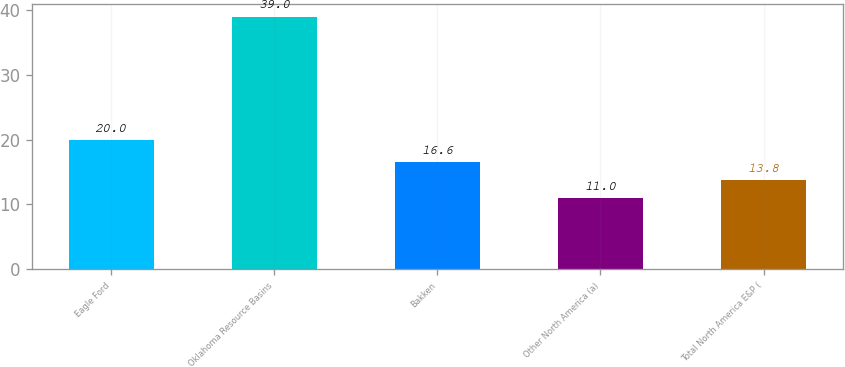Convert chart. <chart><loc_0><loc_0><loc_500><loc_500><bar_chart><fcel>Eagle Ford<fcel>Oklahoma Resource Basins<fcel>Bakken<fcel>Other North America (a)<fcel>Total North America E&P (<nl><fcel>20<fcel>39<fcel>16.6<fcel>11<fcel>13.8<nl></chart> 